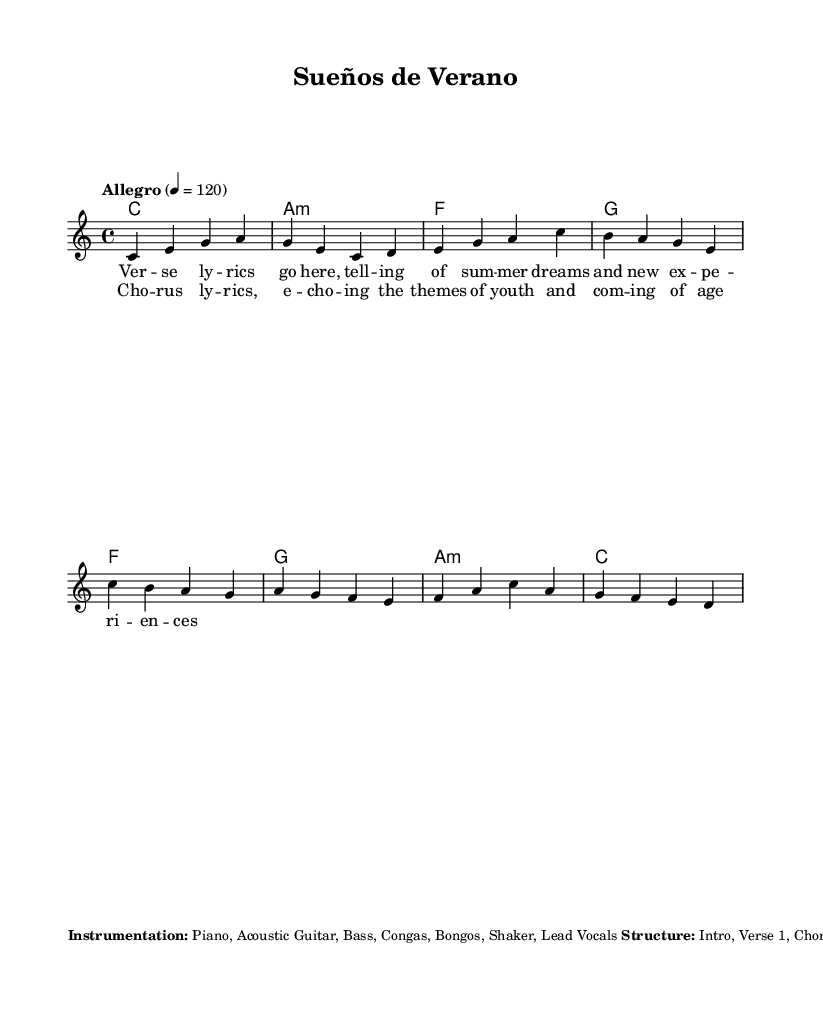What is the key signature of this music? The key signature shown at the beginning indicates C major, which has no sharps or flats.
Answer: C major What is the time signature of the piece? The time signature is identified as 4/4, meaning there are four beats in each measure.
Answer: 4/4 What is the tempo marking for the piece? The tempo marking indicates "Allegro" at a speed of 120 beats per minute, providing a lively pace for the music.
Answer: Allegro 120 How many verses does the song structure have? The structure indicated includes two verses, as identified in the sequence of the song's layout.
Answer: 2 What instruments are included in the instrumentation? The music's instrumentation lists piano, acoustic guitar, bass, congas, bongos, shaker, and lead vocals.
Answer: Piano, Acoustic Guitar, Bass, Congas, Bongos, Shaker, Lead Vocals What themes are echoed in the chorus lyrics? The chorus lyrics reflect themes of youth and coming-of-age experiences, as suggested in the text provided.
Answer: Youth, Coming-of-Age What type of song structure is used? The structure of the song follows a common pop format, which includes an intro, verses, chorus, bridge, and outro sections.
Answer: Intro, Verse, Chorus, Bridge, Outro 